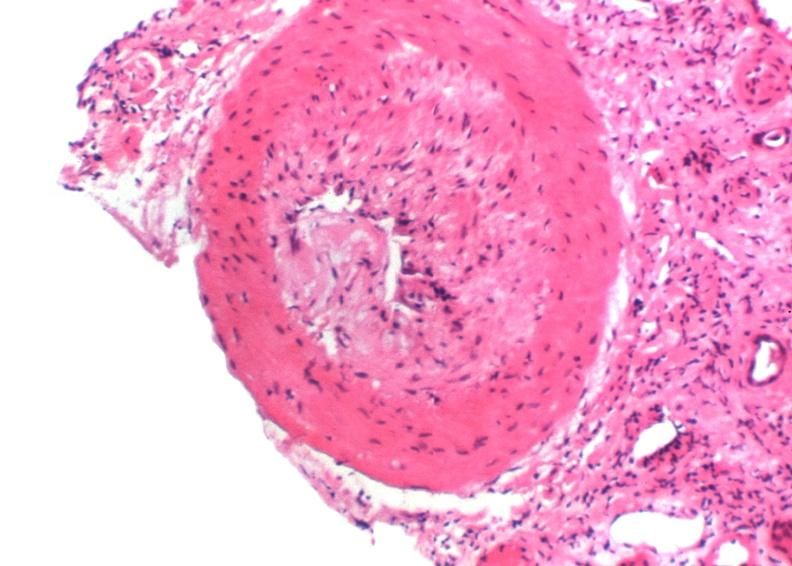what does this image show?
Answer the question using a single word or phrase. Kidney transplant rejection 